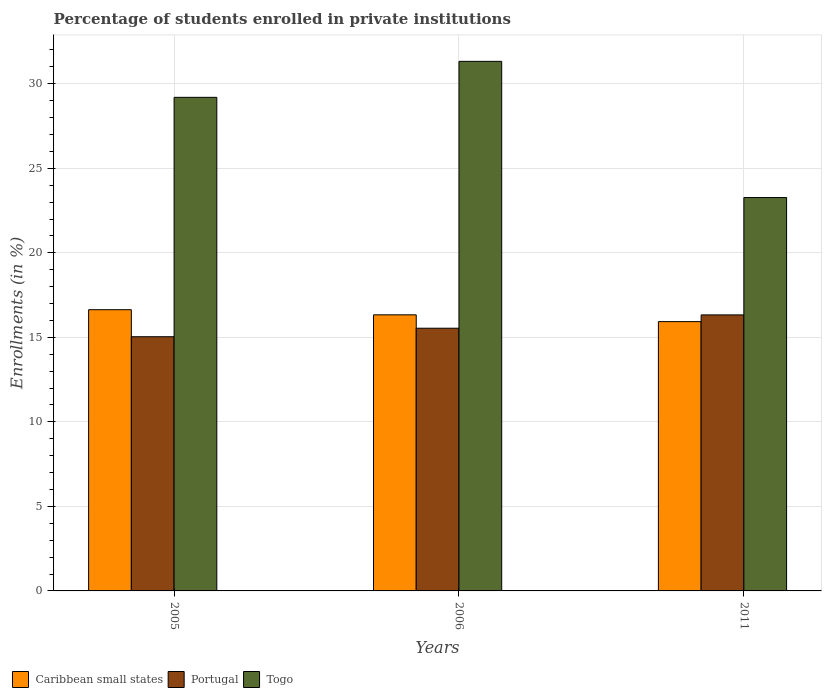How many different coloured bars are there?
Your answer should be compact. 3. How many bars are there on the 1st tick from the right?
Ensure brevity in your answer.  3. What is the label of the 3rd group of bars from the left?
Your answer should be very brief. 2011. What is the percentage of trained teachers in Caribbean small states in 2006?
Offer a very short reply. 16.33. Across all years, what is the maximum percentage of trained teachers in Caribbean small states?
Offer a terse response. 16.64. Across all years, what is the minimum percentage of trained teachers in Togo?
Offer a very short reply. 23.27. In which year was the percentage of trained teachers in Portugal maximum?
Make the answer very short. 2011. What is the total percentage of trained teachers in Portugal in the graph?
Provide a short and direct response. 46.91. What is the difference between the percentage of trained teachers in Portugal in 2005 and that in 2006?
Keep it short and to the point. -0.5. What is the difference between the percentage of trained teachers in Togo in 2011 and the percentage of trained teachers in Caribbean small states in 2006?
Keep it short and to the point. 6.94. What is the average percentage of trained teachers in Togo per year?
Provide a short and direct response. 27.93. In the year 2006, what is the difference between the percentage of trained teachers in Portugal and percentage of trained teachers in Caribbean small states?
Provide a succinct answer. -0.79. What is the ratio of the percentage of trained teachers in Caribbean small states in 2006 to that in 2011?
Give a very brief answer. 1.03. Is the percentage of trained teachers in Caribbean small states in 2005 less than that in 2011?
Provide a succinct answer. No. What is the difference between the highest and the second highest percentage of trained teachers in Togo?
Your answer should be very brief. 2.13. What is the difference between the highest and the lowest percentage of trained teachers in Caribbean small states?
Provide a short and direct response. 0.7. What does the 3rd bar from the left in 2011 represents?
Ensure brevity in your answer.  Togo. What does the 1st bar from the right in 2011 represents?
Give a very brief answer. Togo. Is it the case that in every year, the sum of the percentage of trained teachers in Caribbean small states and percentage of trained teachers in Portugal is greater than the percentage of trained teachers in Togo?
Offer a very short reply. Yes. How many bars are there?
Make the answer very short. 9. How many years are there in the graph?
Keep it short and to the point. 3. Are the values on the major ticks of Y-axis written in scientific E-notation?
Your response must be concise. No. Where does the legend appear in the graph?
Give a very brief answer. Bottom left. How many legend labels are there?
Offer a very short reply. 3. What is the title of the graph?
Your answer should be compact. Percentage of students enrolled in private institutions. Does "Czech Republic" appear as one of the legend labels in the graph?
Offer a very short reply. No. What is the label or title of the X-axis?
Make the answer very short. Years. What is the label or title of the Y-axis?
Ensure brevity in your answer.  Enrollments (in %). What is the Enrollments (in %) of Caribbean small states in 2005?
Offer a terse response. 16.64. What is the Enrollments (in %) in Portugal in 2005?
Ensure brevity in your answer.  15.04. What is the Enrollments (in %) of Togo in 2005?
Offer a terse response. 29.2. What is the Enrollments (in %) of Caribbean small states in 2006?
Offer a terse response. 16.33. What is the Enrollments (in %) of Portugal in 2006?
Your answer should be very brief. 15.54. What is the Enrollments (in %) in Togo in 2006?
Give a very brief answer. 31.33. What is the Enrollments (in %) of Caribbean small states in 2011?
Ensure brevity in your answer.  15.93. What is the Enrollments (in %) of Portugal in 2011?
Make the answer very short. 16.33. What is the Enrollments (in %) of Togo in 2011?
Offer a terse response. 23.27. Across all years, what is the maximum Enrollments (in %) of Caribbean small states?
Your answer should be very brief. 16.64. Across all years, what is the maximum Enrollments (in %) in Portugal?
Give a very brief answer. 16.33. Across all years, what is the maximum Enrollments (in %) of Togo?
Offer a very short reply. 31.33. Across all years, what is the minimum Enrollments (in %) of Caribbean small states?
Keep it short and to the point. 15.93. Across all years, what is the minimum Enrollments (in %) in Portugal?
Your answer should be compact. 15.04. Across all years, what is the minimum Enrollments (in %) in Togo?
Offer a very short reply. 23.27. What is the total Enrollments (in %) of Caribbean small states in the graph?
Ensure brevity in your answer.  48.9. What is the total Enrollments (in %) in Portugal in the graph?
Keep it short and to the point. 46.91. What is the total Enrollments (in %) in Togo in the graph?
Offer a very short reply. 83.8. What is the difference between the Enrollments (in %) of Caribbean small states in 2005 and that in 2006?
Give a very brief answer. 0.3. What is the difference between the Enrollments (in %) in Portugal in 2005 and that in 2006?
Your answer should be very brief. -0.5. What is the difference between the Enrollments (in %) of Togo in 2005 and that in 2006?
Offer a terse response. -2.13. What is the difference between the Enrollments (in %) in Caribbean small states in 2005 and that in 2011?
Give a very brief answer. 0.7. What is the difference between the Enrollments (in %) of Portugal in 2005 and that in 2011?
Provide a succinct answer. -1.29. What is the difference between the Enrollments (in %) in Togo in 2005 and that in 2011?
Your response must be concise. 5.93. What is the difference between the Enrollments (in %) of Caribbean small states in 2006 and that in 2011?
Your response must be concise. 0.4. What is the difference between the Enrollments (in %) of Portugal in 2006 and that in 2011?
Your answer should be very brief. -0.79. What is the difference between the Enrollments (in %) in Togo in 2006 and that in 2011?
Your answer should be very brief. 8.06. What is the difference between the Enrollments (in %) of Caribbean small states in 2005 and the Enrollments (in %) of Portugal in 2006?
Keep it short and to the point. 1.09. What is the difference between the Enrollments (in %) in Caribbean small states in 2005 and the Enrollments (in %) in Togo in 2006?
Keep it short and to the point. -14.69. What is the difference between the Enrollments (in %) of Portugal in 2005 and the Enrollments (in %) of Togo in 2006?
Offer a terse response. -16.29. What is the difference between the Enrollments (in %) in Caribbean small states in 2005 and the Enrollments (in %) in Portugal in 2011?
Offer a terse response. 0.31. What is the difference between the Enrollments (in %) in Caribbean small states in 2005 and the Enrollments (in %) in Togo in 2011?
Provide a short and direct response. -6.64. What is the difference between the Enrollments (in %) of Portugal in 2005 and the Enrollments (in %) of Togo in 2011?
Give a very brief answer. -8.23. What is the difference between the Enrollments (in %) of Caribbean small states in 2006 and the Enrollments (in %) of Portugal in 2011?
Provide a short and direct response. 0. What is the difference between the Enrollments (in %) in Caribbean small states in 2006 and the Enrollments (in %) in Togo in 2011?
Your answer should be very brief. -6.94. What is the difference between the Enrollments (in %) of Portugal in 2006 and the Enrollments (in %) of Togo in 2011?
Give a very brief answer. -7.73. What is the average Enrollments (in %) of Caribbean small states per year?
Provide a short and direct response. 16.3. What is the average Enrollments (in %) of Portugal per year?
Offer a very short reply. 15.64. What is the average Enrollments (in %) of Togo per year?
Make the answer very short. 27.93. In the year 2005, what is the difference between the Enrollments (in %) in Caribbean small states and Enrollments (in %) in Portugal?
Make the answer very short. 1.6. In the year 2005, what is the difference between the Enrollments (in %) in Caribbean small states and Enrollments (in %) in Togo?
Your response must be concise. -12.56. In the year 2005, what is the difference between the Enrollments (in %) of Portugal and Enrollments (in %) of Togo?
Ensure brevity in your answer.  -14.16. In the year 2006, what is the difference between the Enrollments (in %) of Caribbean small states and Enrollments (in %) of Portugal?
Ensure brevity in your answer.  0.79. In the year 2006, what is the difference between the Enrollments (in %) in Caribbean small states and Enrollments (in %) in Togo?
Your answer should be very brief. -14.99. In the year 2006, what is the difference between the Enrollments (in %) in Portugal and Enrollments (in %) in Togo?
Your answer should be compact. -15.79. In the year 2011, what is the difference between the Enrollments (in %) in Caribbean small states and Enrollments (in %) in Portugal?
Offer a terse response. -0.4. In the year 2011, what is the difference between the Enrollments (in %) in Caribbean small states and Enrollments (in %) in Togo?
Give a very brief answer. -7.34. In the year 2011, what is the difference between the Enrollments (in %) in Portugal and Enrollments (in %) in Togo?
Provide a succinct answer. -6.94. What is the ratio of the Enrollments (in %) in Caribbean small states in 2005 to that in 2006?
Offer a very short reply. 1.02. What is the ratio of the Enrollments (in %) in Portugal in 2005 to that in 2006?
Provide a succinct answer. 0.97. What is the ratio of the Enrollments (in %) in Togo in 2005 to that in 2006?
Make the answer very short. 0.93. What is the ratio of the Enrollments (in %) of Caribbean small states in 2005 to that in 2011?
Your response must be concise. 1.04. What is the ratio of the Enrollments (in %) in Portugal in 2005 to that in 2011?
Your answer should be very brief. 0.92. What is the ratio of the Enrollments (in %) of Togo in 2005 to that in 2011?
Keep it short and to the point. 1.25. What is the ratio of the Enrollments (in %) of Caribbean small states in 2006 to that in 2011?
Your answer should be compact. 1.03. What is the ratio of the Enrollments (in %) in Portugal in 2006 to that in 2011?
Offer a terse response. 0.95. What is the ratio of the Enrollments (in %) in Togo in 2006 to that in 2011?
Offer a terse response. 1.35. What is the difference between the highest and the second highest Enrollments (in %) of Caribbean small states?
Your answer should be very brief. 0.3. What is the difference between the highest and the second highest Enrollments (in %) of Portugal?
Your answer should be compact. 0.79. What is the difference between the highest and the second highest Enrollments (in %) in Togo?
Offer a terse response. 2.13. What is the difference between the highest and the lowest Enrollments (in %) in Caribbean small states?
Ensure brevity in your answer.  0.7. What is the difference between the highest and the lowest Enrollments (in %) in Portugal?
Your answer should be very brief. 1.29. What is the difference between the highest and the lowest Enrollments (in %) in Togo?
Your response must be concise. 8.06. 